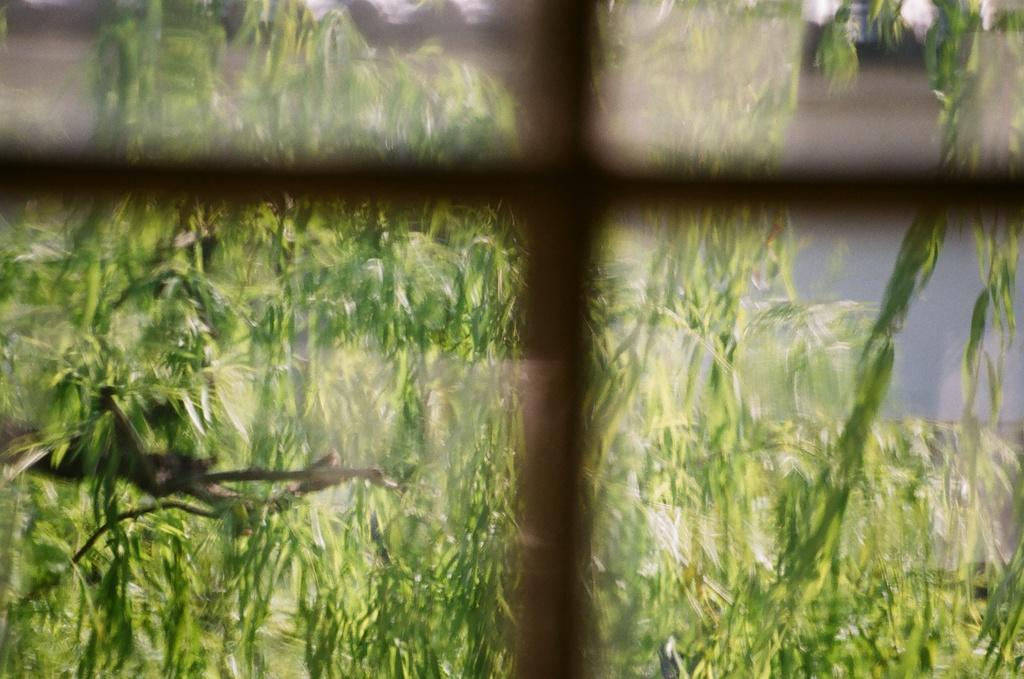What color are the leaves in the image? The leaves in the image are green. Can you describe the overall clarity of the image? The image is slightly blurry. What type of cap is the person wearing in the image? There is no person or cap present in the image; it only features green leaves. What kind of bait is being used to catch fish in the image? There is no fishing or bait present in the image; it only features green leaves. 